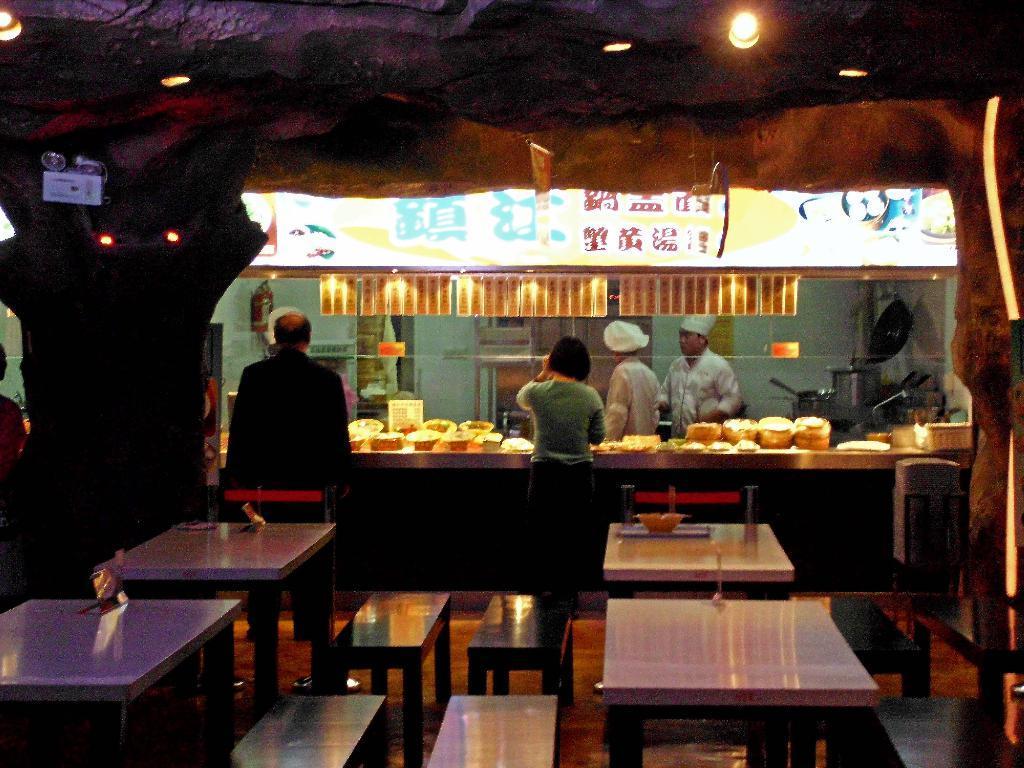Can you describe this image briefly? There are four table and few benches. I can see a bowl,a tray placed on the table. Here is the woman and man standing. these are bowls and few objects placed on the cabin. This is the name board. This looks like a banner hanging. I can see few utensils placed here. There are two people standing inside the cabin. These are the lights. 